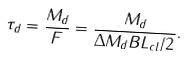<formula> <loc_0><loc_0><loc_500><loc_500>\tau _ { d } = \frac { M _ { d } } { F } = \frac { M _ { d } } { \Delta M _ { d } B L _ { c l } / 2 } .</formula> 